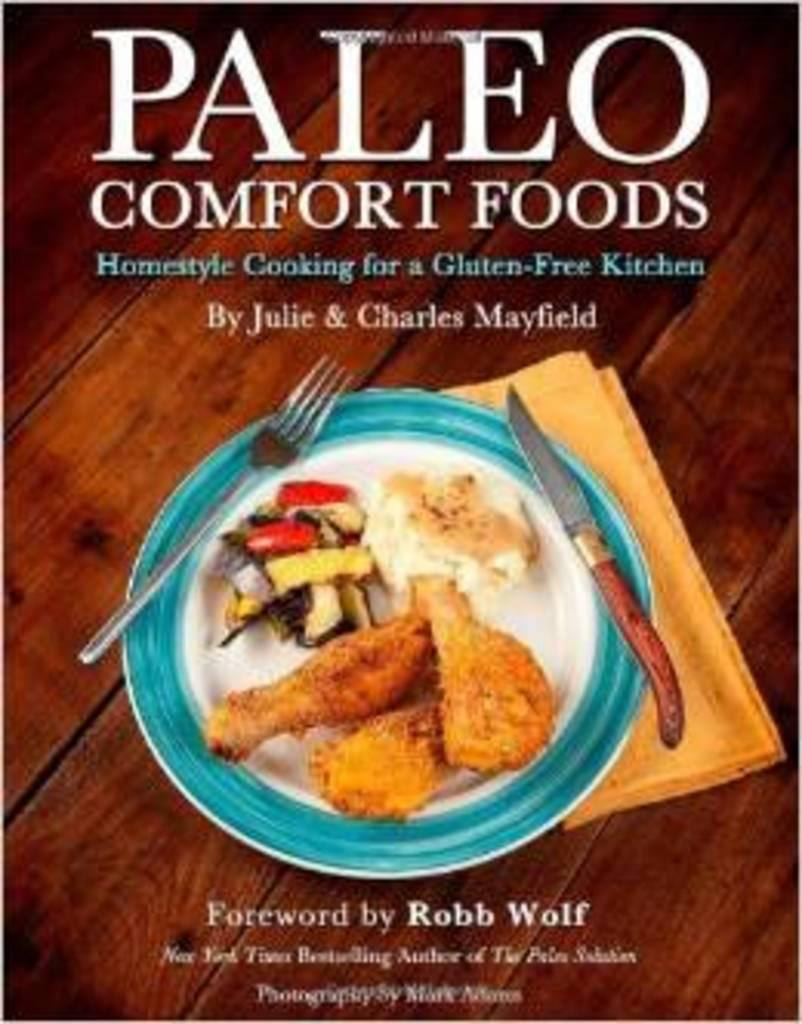What type of surface is present in the image? There is a table in the image. What can be seen written or printed on the table? There is some text visible on the table. What is on the plate that is on the table? There is a plate with food on the table. What utensils are present on the table? A knife and a fork are present on the table. What is covering the table in the image? There is a cloth on the table. What type of leather material is used to make the dust on the table in the image? There is no leather or dust present in the image. The table is covered by a cloth, and there is no mention of any dust or leather material. 